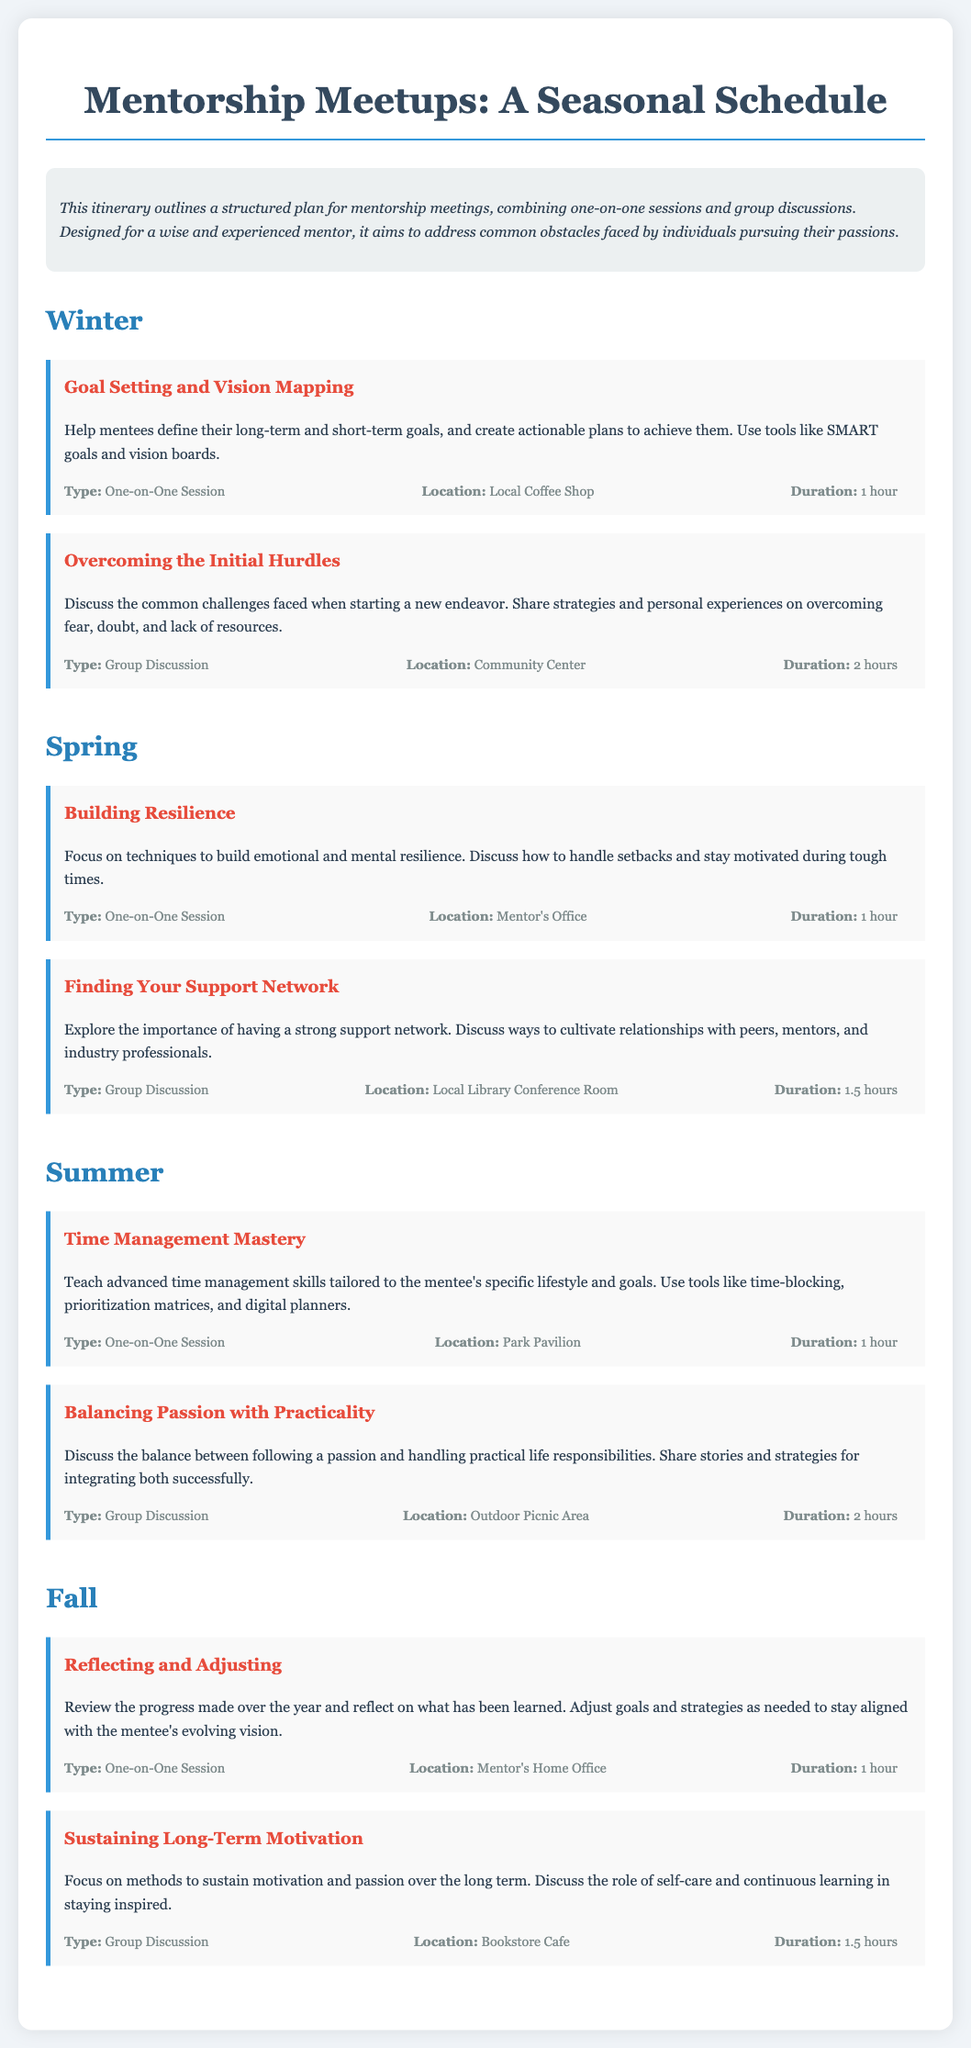What is the main purpose of the itinerary? The itinerary outlines a structured plan for mentorship meetings, combining one-on-one sessions and group discussions to address common obstacles.
Answer: Address common obstacles How long is the "Overcoming the Initial Hurdles" group discussion? The duration of the "Overcoming the Initial Hurdles" activity is specified in the document as 2 hours.
Answer: 2 hours What is the location for the "Time Management Mastery" session? The document specifies the location for the "Time Management Mastery" one-on-one session as the Park Pavilion.
Answer: Park Pavilion Which season includes the "Building Resilience" session? The session "Building Resilience" is listed under the Spring season in the itinerary.
Answer: Spring How many group discussions are scheduled in the Summer season? The itinerary lists two activities in the Summer season, one of which is a group discussion, making the count for group discussions one.
Answer: One What is the duration for the "Sustaining Long-Term Motivation" group discussion? The document states that the duration of the "Sustaining Long-Term Motivation" group discussion is 1.5 hours.
Answer: 1.5 hours What type of session is "Goal Setting and Vision Mapping"? According to the document, the "Goal Setting and Vision Mapping" is categorized as a One-on-One Session.
Answer: One-on-One Session What is the theme for Fall's first activity? The first activity of Fall focuses on reviewing the progress made over the year, specifically titled "Reflecting and Adjusting."
Answer: Reflecting and Adjusting How long does the "Finding Your Support Network" discussion last? The document mentions that the "Finding Your Support Network" group discussion lasts for 1.5 hours.
Answer: 1.5 hours 